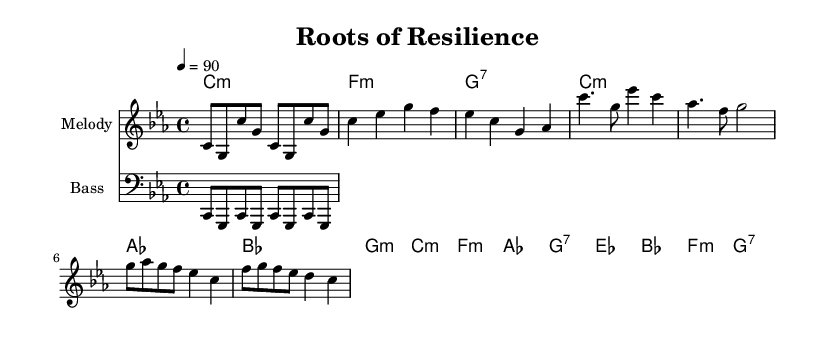What is the key signature of this music? The key signature is C minor, indicated by three flats in the signature at the beginning of the score.
Answer: C minor What is the time signature of this music? The time signature is 4/4, which means there are four beats in a measure and the quarter note gets one beat, as shown at the beginning of the score.
Answer: 4/4 What is the tempo marking for this piece? The tempo marking is 90 beats per minute, specified in the tempo indication, which dictates the speed of the music.
Answer: 90 How many measures are there in the verse section? The verse section consists of four measures, which can be determined by counting the measures present in the melody section labeled as "Verse".
Answer: 4 What kind of progression is used in the chorus? The chorus features a common pop chord progression, particularly the I-IV-vi-V progression, characterized by the chords played: C minor, F minor, A flat, and G dominant 7th.
Answer: I-IV-vi-V What is the overall mood conveyed by the melody and harmony? The overall mood is reflective and resilient, as indicated by the minor key and the melodic choices that emphasize themes of strength and overcoming challenges.
Answer: Reflective and resilient How does the bass line support the melody? The bass line provides a rhythmic foundation and reinforces the harmonic progression, mirroring the chords while enhancing the groove that is typical in Hip Hop, thus supporting the melody effectively.
Answer: It provides rhythmic foundation 